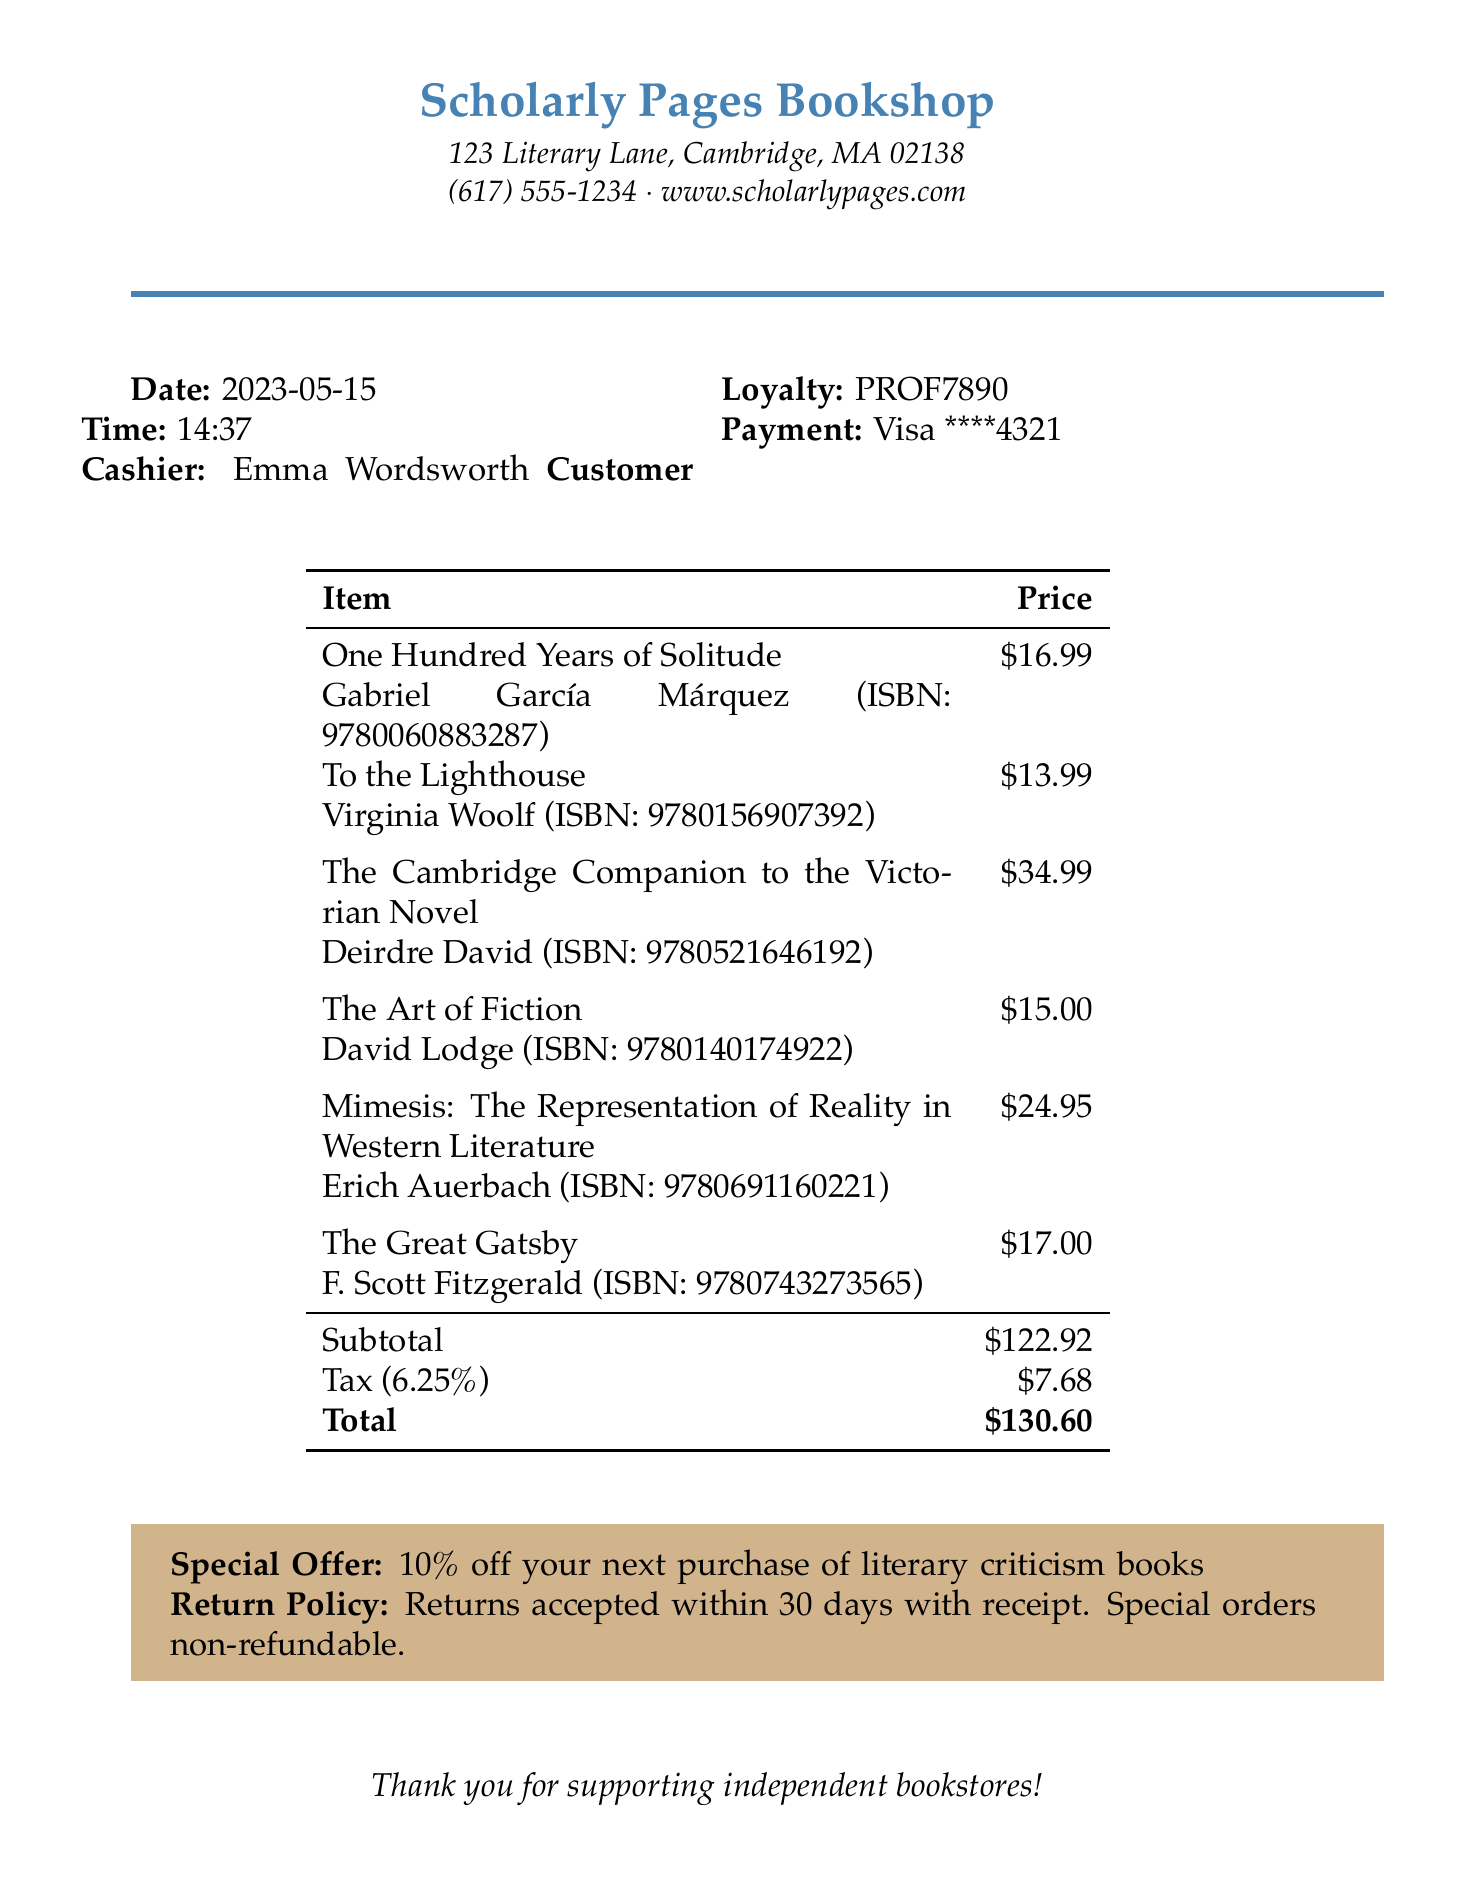What is the name of the bookstore? The name of the bookstore is clearly mentioned at the top of the receipt.
Answer: Scholarly Pages Bookshop Who is the cashier? The cashier's name is listed next to the transaction details.
Answer: Emma Wordsworth What is the date of the purchase? The date of the purchase is provided in the document.
Answer: 2023-05-15 How much did "The Great Gatsby" cost? The cost of "The Great Gatsby" is included in the list of purchased items.
Answer: 17.00 What was the subtotal amount? The subtotal amount is summarized at the end of the item list.
Answer: 122.92 What is the ISBN number for "Mimesis: The Representation of Reality in Western Literature"? The ISBN number for the book is included next to its title on the receipt.
Answer: 9780691160221 What percentage off is offered for the next purchase of literary criticism books? The special offer is mentioned in a dedicated section of the receipt.
Answer: 10% What is the tax rate applied to the purchase? The tax rate can be found in the tax calculation section of the receipt.
Answer: 6.25% What is the return policy duration mentioned? The return policy is noted in the special section aimed at customer information.
Answer: 30 days 